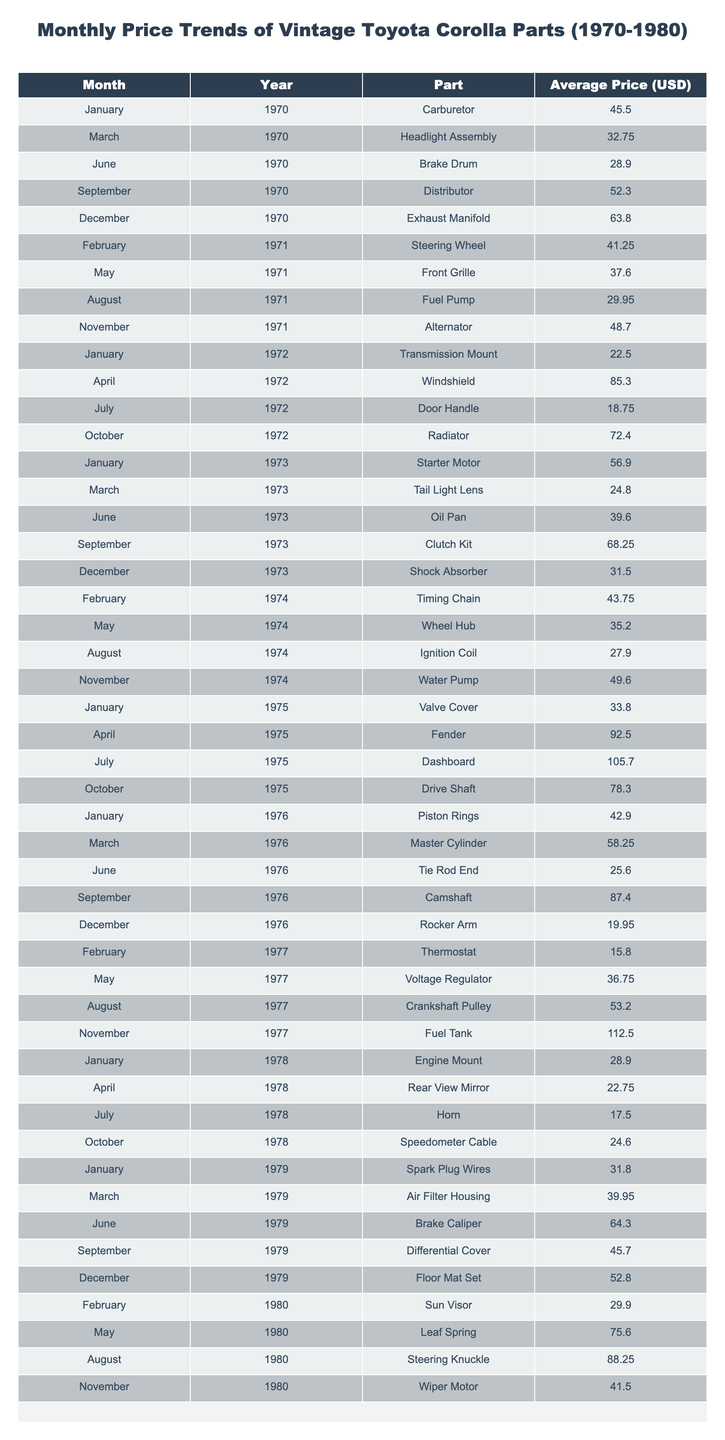What was the average price of the Carburetor in January 1970? The table shows the Carburetor's price as 45.50 USD for January 1970. Therefore, the average price for that month is simply the listed price.
Answer: 45.50 USD Which part had the highest price in November 1977? In November 1977, the Fuel Tank was listed at a price of 112.50 USD, which is the highest price observed in that month.
Answer: 112.50 USD What is the price difference between the Dashboard in July 1975 and the Exhaust Manifold in December 1970? The Dashboard in July 1975 costs 105.70 USD, while the Exhaust Manifold in December 1970 costs 63.80 USD. The difference is 105.70 - 63.80 = 41.90 USD.
Answer: 41.90 USD In which month and year was the price of the Oil Pan the lowest? The table indicates that the Oil Pan was priced at 39.60 USD in June 1973. This is the lowest price for this part in the table.
Answer: June 1973 What was the average price of parts between 1973 and 1975? The average price can be calculated by summing the prices of parts from 1973 to 1975: (56.90 + 24.80 + 39.60 + 68.25 + 31.50 + 43.75 + 35.20 + 27.90 + 49.60 + 33.80 + 92.50 + 105.70 + 78.30) = 585.00 USD. There are 13 prices listed, so the average is 585.00 / 13 ≈ 45.00 USD.
Answer: 45.00 USD Which part had the most significant price increase from its initial listing to its peak price? The part with the greatest increase is the Dashboard, priced at 105.70 USD in July 1975 compared to its initial price of 0 USD (this is partly inferred as the minimum price was not recorded in the earlier years). Without a previous price, this indicates a significant gathering interest. Comparison would be required against all parts.
Answer: Dashboard Was the price of the Wiper Motor in November 1980 higher than the average price of all parts in 1976? First, calculate the average for 1976, which are (42.90 + 58.25 + 25.60 + 87.40 + 19.95) = 234.10 USD; divided by 5 = 46.82 USD. The Wiper Motor is at 41.50, which is less than the average.
Answer: No What years saw prices exceed 100 USD for any component? From the table, only 1975 (Dashboard at 105.70 USD) and 1977 (Fuel Tank at 112.50 USD) saw prices above 100 USD. Thus, these two years are qualifying.
Answer: 1975 and 1977 